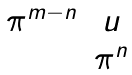<formula> <loc_0><loc_0><loc_500><loc_500>\begin{matrix} \pi ^ { m - n } & u \\ & \pi ^ { n } \end{matrix}</formula> 